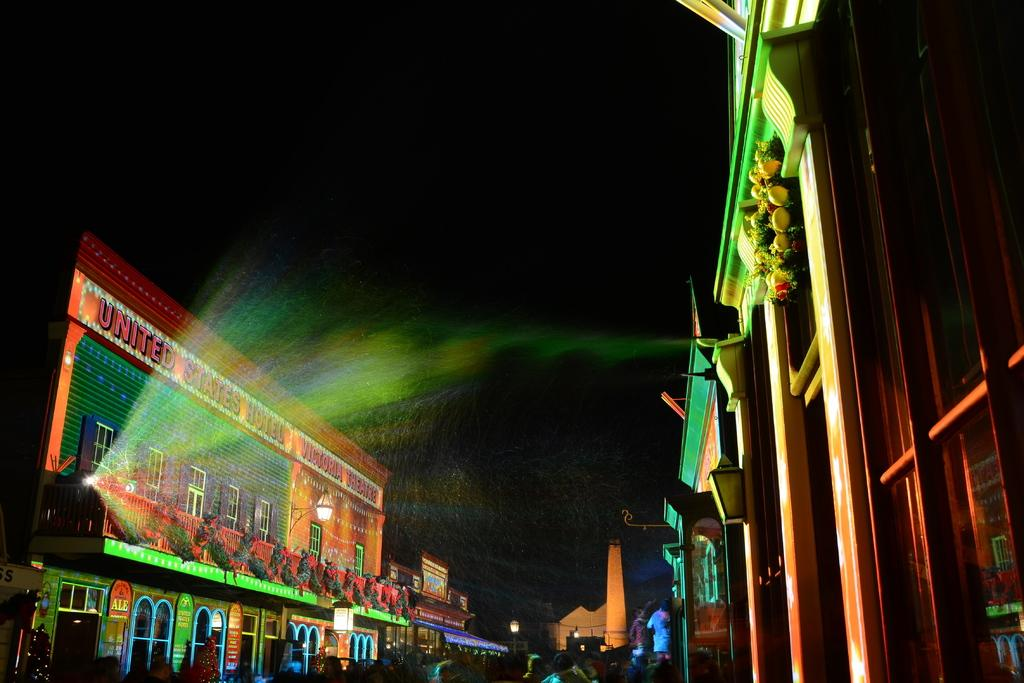Who or what can be seen in the image? There are people in the image. What else is present in the image besides people? There are decorative items and buildings in the image. Can you describe the buildings in the image? The buildings have lights on them. What is the color of the background in the image? The background of the image is dark. How many vases are visible in the image? There is no vase present in the image. What type of waste can be seen on the ground in the image? There is no waste visible in the image; it only features people, decorative items, buildings, and lights. 